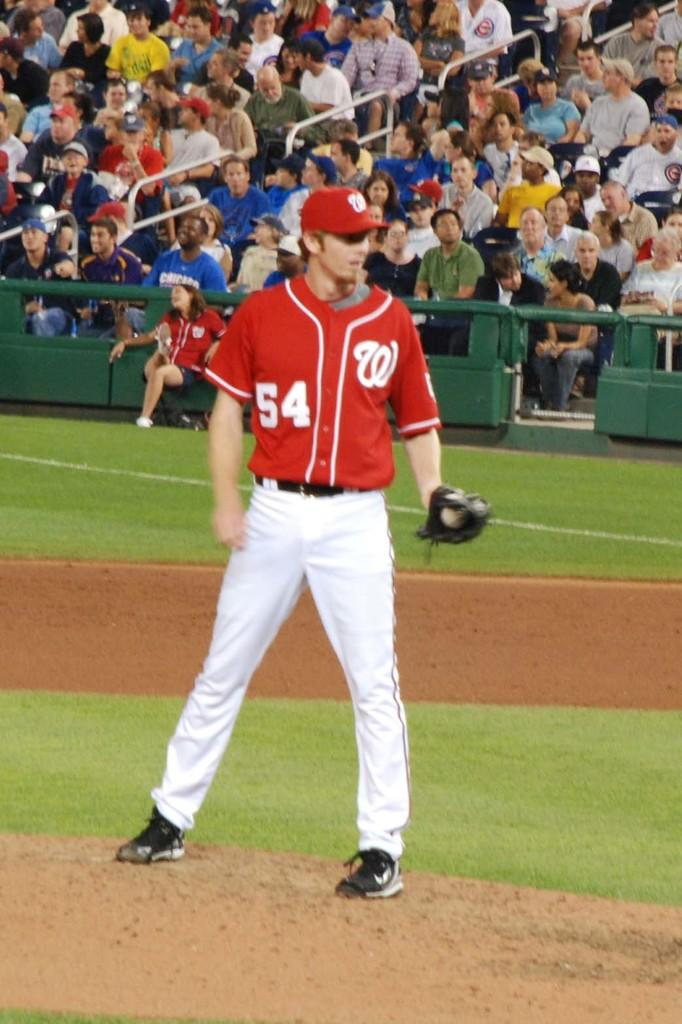<image>
Render a clear and concise summary of the photo. a pitcher that has the letter W on their jersey 